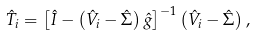<formula> <loc_0><loc_0><loc_500><loc_500>\hat { T } _ { i } = \left [ \hat { I } - \left ( \hat { V } _ { i } - \hat { \Sigma } \right ) \hat { g } \right ] ^ { - 1 } \left ( \hat { V } _ { i } - \hat { \Sigma } \right ) ,</formula> 